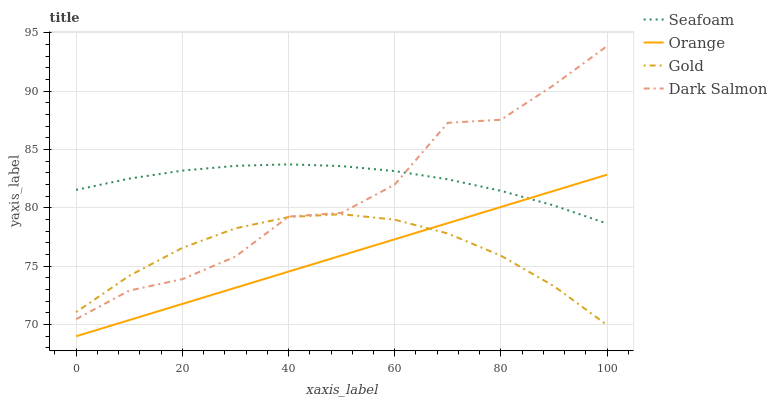Does Orange have the minimum area under the curve?
Answer yes or no. Yes. Does Seafoam have the maximum area under the curve?
Answer yes or no. Yes. Does Gold have the minimum area under the curve?
Answer yes or no. No. Does Gold have the maximum area under the curve?
Answer yes or no. No. Is Orange the smoothest?
Answer yes or no. Yes. Is Dark Salmon the roughest?
Answer yes or no. Yes. Is Seafoam the smoothest?
Answer yes or no. No. Is Seafoam the roughest?
Answer yes or no. No. Does Orange have the lowest value?
Answer yes or no. Yes. Does Gold have the lowest value?
Answer yes or no. No. Does Dark Salmon have the highest value?
Answer yes or no. Yes. Does Seafoam have the highest value?
Answer yes or no. No. Is Orange less than Dark Salmon?
Answer yes or no. Yes. Is Seafoam greater than Gold?
Answer yes or no. Yes. Does Seafoam intersect Dark Salmon?
Answer yes or no. Yes. Is Seafoam less than Dark Salmon?
Answer yes or no. No. Is Seafoam greater than Dark Salmon?
Answer yes or no. No. Does Orange intersect Dark Salmon?
Answer yes or no. No. 